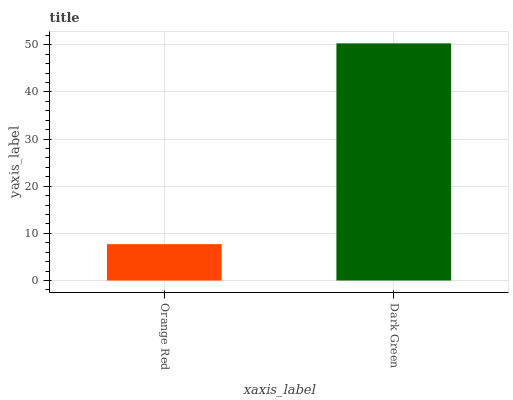Is Orange Red the minimum?
Answer yes or no. Yes. Is Dark Green the maximum?
Answer yes or no. Yes. Is Dark Green the minimum?
Answer yes or no. No. Is Dark Green greater than Orange Red?
Answer yes or no. Yes. Is Orange Red less than Dark Green?
Answer yes or no. Yes. Is Orange Red greater than Dark Green?
Answer yes or no. No. Is Dark Green less than Orange Red?
Answer yes or no. No. Is Dark Green the high median?
Answer yes or no. Yes. Is Orange Red the low median?
Answer yes or no. Yes. Is Orange Red the high median?
Answer yes or no. No. Is Dark Green the low median?
Answer yes or no. No. 